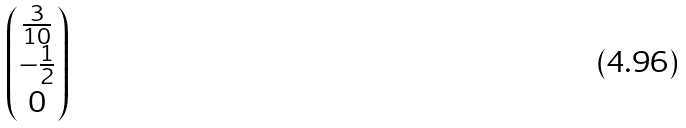Convert formula to latex. <formula><loc_0><loc_0><loc_500><loc_500>\begin{pmatrix} \frac { 3 } { 1 0 } \\ - \frac { 1 } { 2 } \\ 0 \end{pmatrix}</formula> 